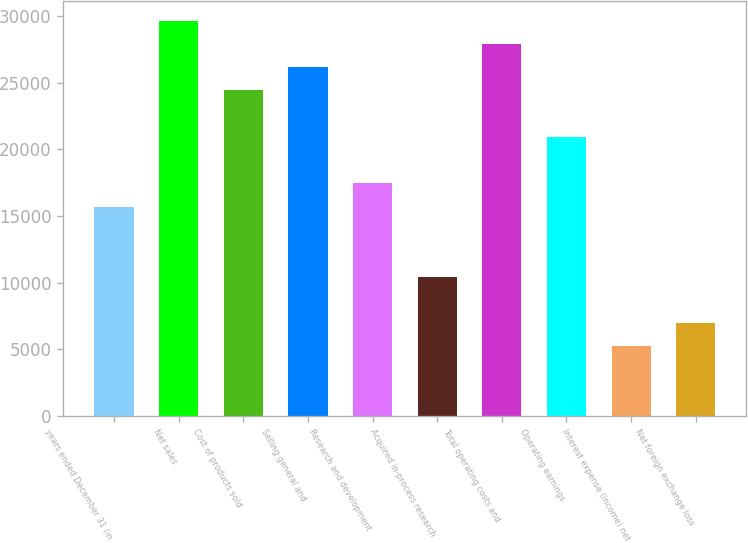Convert chart to OTSL. <chart><loc_0><loc_0><loc_500><loc_500><bar_chart><fcel>years ended December 31 (in<fcel>Net sales<fcel>Cost of products sold<fcel>Selling general and<fcel>Research and development<fcel>Acquired in-process research<fcel>Total operating costs and<fcel>Operating earnings<fcel>Interest expense (income) net<fcel>Net foreign exchange loss<nl><fcel>15699.8<fcel>29653.4<fcel>24420.8<fcel>26165<fcel>17444<fcel>10467.2<fcel>27909.2<fcel>20932.4<fcel>5234.6<fcel>6978.8<nl></chart> 